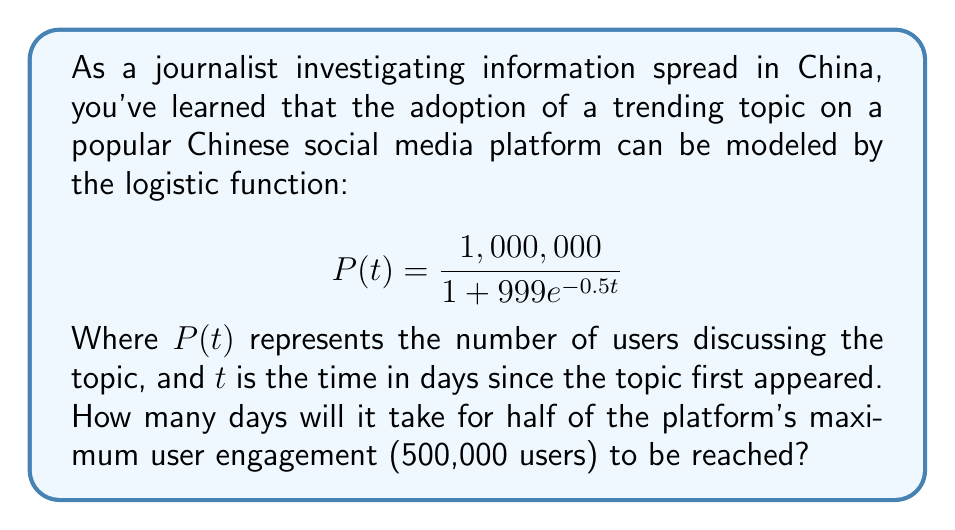Provide a solution to this math problem. To solve this problem, we need to follow these steps:

1) The logistic function given is:
   $$P(t) = \frac{1,000,000}{1 + 999e^{-0.5t}}$$

2) We want to find $t$ when $P(t) = 500,000$ (half of the maximum 1,000,000).

3) Let's set up the equation:
   $$500,000 = \frac{1,000,000}{1 + 999e^{-0.5t}}$$

4) Multiply both sides by $(1 + 999e^{-0.5t})$:
   $$500,000(1 + 999e^{-0.5t}) = 1,000,000$$

5) Expand the left side:
   $$500,000 + 499,500,000e^{-0.5t} = 1,000,000$$

6) Subtract 500,000 from both sides:
   $$499,500,000e^{-0.5t} = 500,000$$

7) Divide both sides by 499,500,000:
   $$e^{-0.5t} = \frac{1}{999}$$

8) Take the natural log of both sides:
   $$-0.5t = \ln(\frac{1}{999})$$

9) Divide both sides by -0.5:
   $$t = -\frac{2\ln(\frac{1}{999})}{1} = 2\ln(999)$$

10) Calculate the value (you can use a calculator for this):
    $$t \approx 13.81$$

Therefore, it will take approximately 13.81 days for the topic to reach 500,000 users.
Answer: 13.81 days 